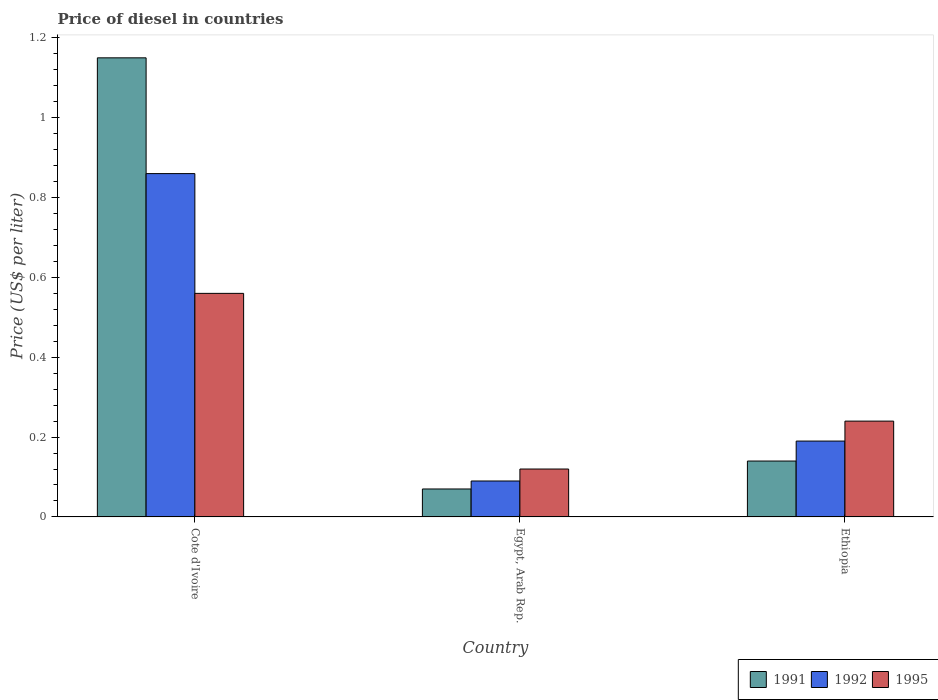How many bars are there on the 2nd tick from the left?
Provide a succinct answer. 3. How many bars are there on the 3rd tick from the right?
Provide a short and direct response. 3. What is the label of the 1st group of bars from the left?
Provide a short and direct response. Cote d'Ivoire. What is the price of diesel in 1995 in Ethiopia?
Make the answer very short. 0.24. Across all countries, what is the maximum price of diesel in 1992?
Your response must be concise. 0.86. Across all countries, what is the minimum price of diesel in 1995?
Provide a succinct answer. 0.12. In which country was the price of diesel in 1992 maximum?
Your response must be concise. Cote d'Ivoire. In which country was the price of diesel in 1992 minimum?
Keep it short and to the point. Egypt, Arab Rep. What is the total price of diesel in 1992 in the graph?
Keep it short and to the point. 1.14. What is the difference between the price of diesel in 1991 in Egypt, Arab Rep. and that in Ethiopia?
Make the answer very short. -0.07. What is the difference between the price of diesel in 1992 in Egypt, Arab Rep. and the price of diesel in 1991 in Ethiopia?
Your answer should be compact. -0.05. What is the average price of diesel in 1992 per country?
Keep it short and to the point. 0.38. What is the difference between the price of diesel of/in 1991 and price of diesel of/in 1992 in Ethiopia?
Offer a terse response. -0.05. Is the difference between the price of diesel in 1991 in Cote d'Ivoire and Ethiopia greater than the difference between the price of diesel in 1992 in Cote d'Ivoire and Ethiopia?
Provide a short and direct response. Yes. What is the difference between the highest and the second highest price of diesel in 1992?
Make the answer very short. 0.77. What is the difference between the highest and the lowest price of diesel in 1991?
Offer a very short reply. 1.08. What does the 1st bar from the left in Ethiopia represents?
Ensure brevity in your answer.  1991. Is it the case that in every country, the sum of the price of diesel in 1995 and price of diesel in 1992 is greater than the price of diesel in 1991?
Your answer should be very brief. Yes. How many countries are there in the graph?
Give a very brief answer. 3. What is the difference between two consecutive major ticks on the Y-axis?
Your answer should be compact. 0.2. Are the values on the major ticks of Y-axis written in scientific E-notation?
Your response must be concise. No. Where does the legend appear in the graph?
Offer a terse response. Bottom right. What is the title of the graph?
Your answer should be very brief. Price of diesel in countries. What is the label or title of the X-axis?
Make the answer very short. Country. What is the label or title of the Y-axis?
Keep it short and to the point. Price (US$ per liter). What is the Price (US$ per liter) in 1991 in Cote d'Ivoire?
Give a very brief answer. 1.15. What is the Price (US$ per liter) in 1992 in Cote d'Ivoire?
Your answer should be compact. 0.86. What is the Price (US$ per liter) of 1995 in Cote d'Ivoire?
Make the answer very short. 0.56. What is the Price (US$ per liter) of 1991 in Egypt, Arab Rep.?
Ensure brevity in your answer.  0.07. What is the Price (US$ per liter) in 1992 in Egypt, Arab Rep.?
Provide a succinct answer. 0.09. What is the Price (US$ per liter) in 1995 in Egypt, Arab Rep.?
Keep it short and to the point. 0.12. What is the Price (US$ per liter) of 1991 in Ethiopia?
Make the answer very short. 0.14. What is the Price (US$ per liter) of 1992 in Ethiopia?
Offer a very short reply. 0.19. What is the Price (US$ per liter) of 1995 in Ethiopia?
Provide a short and direct response. 0.24. Across all countries, what is the maximum Price (US$ per liter) in 1991?
Ensure brevity in your answer.  1.15. Across all countries, what is the maximum Price (US$ per liter) of 1992?
Offer a terse response. 0.86. Across all countries, what is the maximum Price (US$ per liter) in 1995?
Your answer should be very brief. 0.56. Across all countries, what is the minimum Price (US$ per liter) in 1991?
Provide a short and direct response. 0.07. Across all countries, what is the minimum Price (US$ per liter) of 1992?
Your answer should be very brief. 0.09. Across all countries, what is the minimum Price (US$ per liter) in 1995?
Make the answer very short. 0.12. What is the total Price (US$ per liter) of 1991 in the graph?
Ensure brevity in your answer.  1.36. What is the total Price (US$ per liter) of 1992 in the graph?
Make the answer very short. 1.14. What is the total Price (US$ per liter) in 1995 in the graph?
Make the answer very short. 0.92. What is the difference between the Price (US$ per liter) of 1992 in Cote d'Ivoire and that in Egypt, Arab Rep.?
Your answer should be very brief. 0.77. What is the difference between the Price (US$ per liter) of 1995 in Cote d'Ivoire and that in Egypt, Arab Rep.?
Make the answer very short. 0.44. What is the difference between the Price (US$ per liter) in 1991 in Cote d'Ivoire and that in Ethiopia?
Your response must be concise. 1.01. What is the difference between the Price (US$ per liter) in 1992 in Cote d'Ivoire and that in Ethiopia?
Offer a terse response. 0.67. What is the difference between the Price (US$ per liter) in 1995 in Cote d'Ivoire and that in Ethiopia?
Your response must be concise. 0.32. What is the difference between the Price (US$ per liter) in 1991 in Egypt, Arab Rep. and that in Ethiopia?
Ensure brevity in your answer.  -0.07. What is the difference between the Price (US$ per liter) of 1995 in Egypt, Arab Rep. and that in Ethiopia?
Your answer should be very brief. -0.12. What is the difference between the Price (US$ per liter) in 1991 in Cote d'Ivoire and the Price (US$ per liter) in 1992 in Egypt, Arab Rep.?
Keep it short and to the point. 1.06. What is the difference between the Price (US$ per liter) in 1992 in Cote d'Ivoire and the Price (US$ per liter) in 1995 in Egypt, Arab Rep.?
Your response must be concise. 0.74. What is the difference between the Price (US$ per liter) in 1991 in Cote d'Ivoire and the Price (US$ per liter) in 1995 in Ethiopia?
Make the answer very short. 0.91. What is the difference between the Price (US$ per liter) of 1992 in Cote d'Ivoire and the Price (US$ per liter) of 1995 in Ethiopia?
Keep it short and to the point. 0.62. What is the difference between the Price (US$ per liter) of 1991 in Egypt, Arab Rep. and the Price (US$ per liter) of 1992 in Ethiopia?
Your response must be concise. -0.12. What is the difference between the Price (US$ per liter) in 1991 in Egypt, Arab Rep. and the Price (US$ per liter) in 1995 in Ethiopia?
Provide a succinct answer. -0.17. What is the average Price (US$ per liter) in 1991 per country?
Offer a very short reply. 0.45. What is the average Price (US$ per liter) in 1992 per country?
Ensure brevity in your answer.  0.38. What is the average Price (US$ per liter) in 1995 per country?
Your answer should be very brief. 0.31. What is the difference between the Price (US$ per liter) of 1991 and Price (US$ per liter) of 1992 in Cote d'Ivoire?
Your response must be concise. 0.29. What is the difference between the Price (US$ per liter) in 1991 and Price (US$ per liter) in 1995 in Cote d'Ivoire?
Your answer should be very brief. 0.59. What is the difference between the Price (US$ per liter) in 1992 and Price (US$ per liter) in 1995 in Cote d'Ivoire?
Provide a succinct answer. 0.3. What is the difference between the Price (US$ per liter) of 1991 and Price (US$ per liter) of 1992 in Egypt, Arab Rep.?
Offer a terse response. -0.02. What is the difference between the Price (US$ per liter) in 1991 and Price (US$ per liter) in 1995 in Egypt, Arab Rep.?
Ensure brevity in your answer.  -0.05. What is the difference between the Price (US$ per liter) in 1992 and Price (US$ per liter) in 1995 in Egypt, Arab Rep.?
Your answer should be compact. -0.03. What is the difference between the Price (US$ per liter) in 1991 and Price (US$ per liter) in 1995 in Ethiopia?
Make the answer very short. -0.1. What is the ratio of the Price (US$ per liter) of 1991 in Cote d'Ivoire to that in Egypt, Arab Rep.?
Your response must be concise. 16.43. What is the ratio of the Price (US$ per liter) in 1992 in Cote d'Ivoire to that in Egypt, Arab Rep.?
Offer a terse response. 9.56. What is the ratio of the Price (US$ per liter) in 1995 in Cote d'Ivoire to that in Egypt, Arab Rep.?
Your answer should be compact. 4.67. What is the ratio of the Price (US$ per liter) in 1991 in Cote d'Ivoire to that in Ethiopia?
Your answer should be very brief. 8.21. What is the ratio of the Price (US$ per liter) of 1992 in Cote d'Ivoire to that in Ethiopia?
Your response must be concise. 4.53. What is the ratio of the Price (US$ per liter) of 1995 in Cote d'Ivoire to that in Ethiopia?
Make the answer very short. 2.33. What is the ratio of the Price (US$ per liter) of 1991 in Egypt, Arab Rep. to that in Ethiopia?
Make the answer very short. 0.5. What is the ratio of the Price (US$ per liter) of 1992 in Egypt, Arab Rep. to that in Ethiopia?
Keep it short and to the point. 0.47. What is the ratio of the Price (US$ per liter) in 1995 in Egypt, Arab Rep. to that in Ethiopia?
Offer a very short reply. 0.5. What is the difference between the highest and the second highest Price (US$ per liter) of 1992?
Give a very brief answer. 0.67. What is the difference between the highest and the second highest Price (US$ per liter) of 1995?
Offer a very short reply. 0.32. What is the difference between the highest and the lowest Price (US$ per liter) of 1991?
Give a very brief answer. 1.08. What is the difference between the highest and the lowest Price (US$ per liter) of 1992?
Ensure brevity in your answer.  0.77. What is the difference between the highest and the lowest Price (US$ per liter) in 1995?
Your answer should be compact. 0.44. 